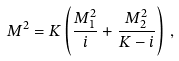Convert formula to latex. <formula><loc_0><loc_0><loc_500><loc_500>M ^ { 2 } = K \left ( \frac { M _ { 1 } ^ { 2 } } { i } + \frac { M _ { 2 } ^ { 2 } } { K - i } \right ) \, ,</formula> 